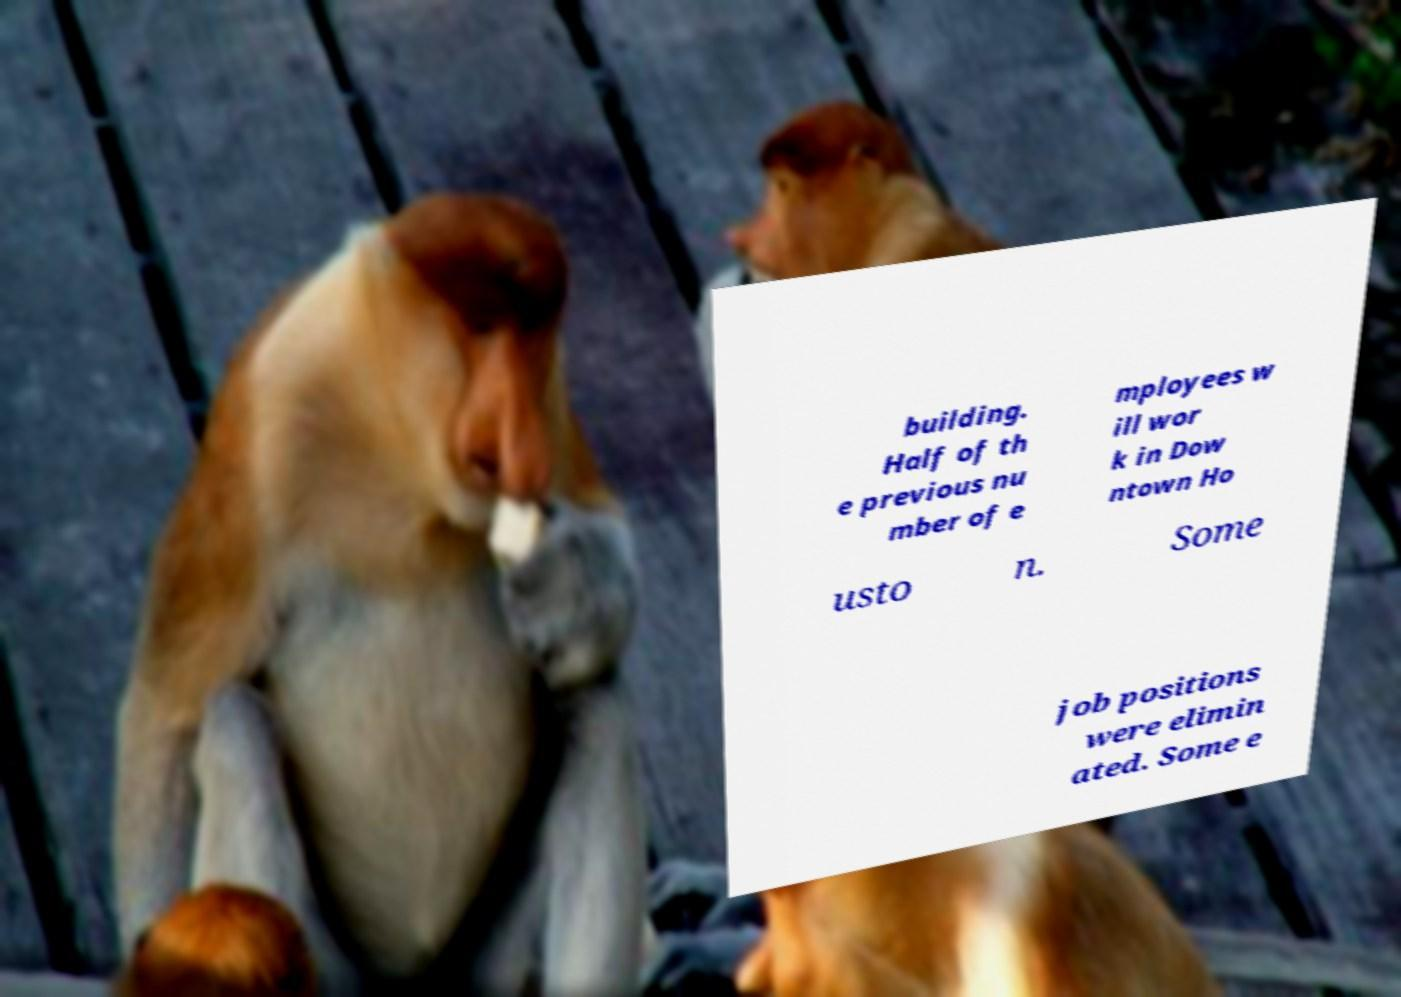Could you extract and type out the text from this image? building. Half of th e previous nu mber of e mployees w ill wor k in Dow ntown Ho usto n. Some job positions were elimin ated. Some e 